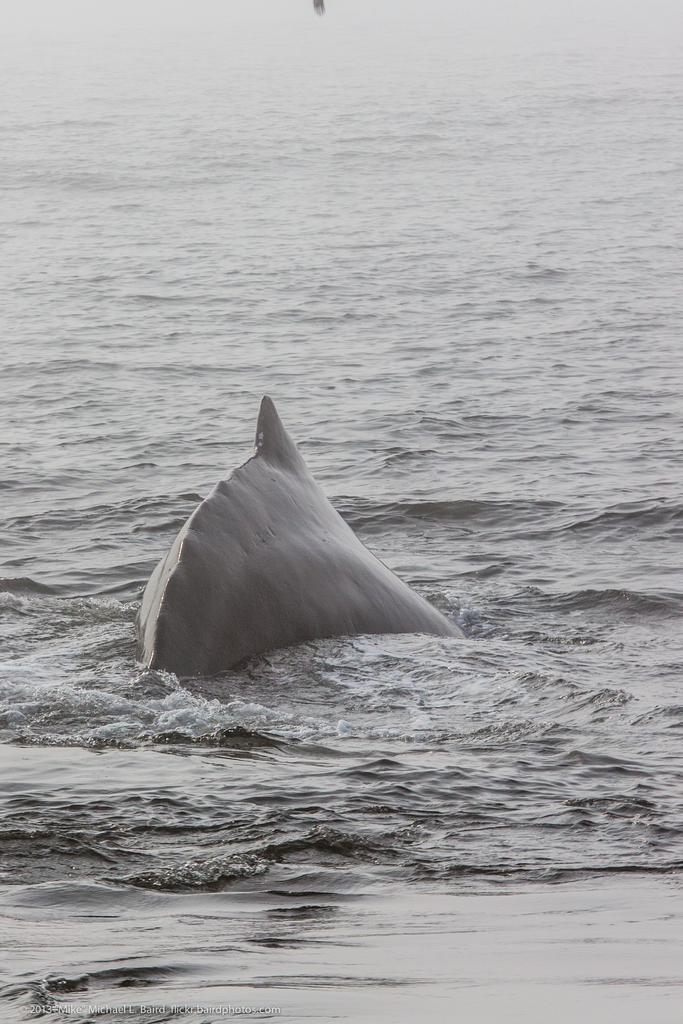How would you summarize this image in a sentence or two? In this image on the water body there is a fish. 